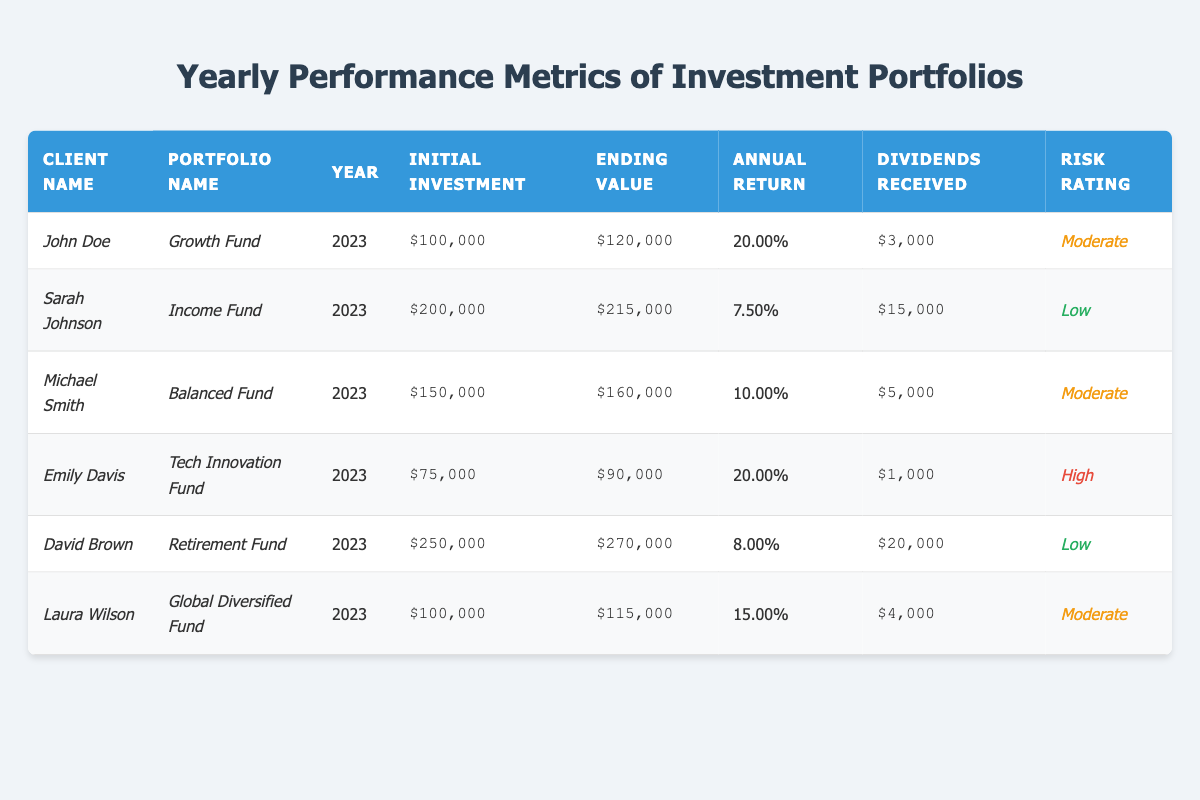What is the annual return percentage for John Doe's Growth Fund? The annual return percentage is listed directly next to John Doe's Growth Fund in the table, which reads 20.00%.
Answer: 20.00% How much did Sarah Johnson receive in dividends from the Income Fund? The table indicates that Sarah Johnson received $15,000 in dividends from the Income Fund.
Answer: $15,000 Which portfolio has the highest ending value? By looking through the ending values, David Brown's Retirement Fund has the highest ending value at $270,000.
Answer: $270,000 What is the average initial investment across all portfolios? The initial investments are $100,000, $200,000, $150,000, $75,000, $250,000, and $100,000. Adding these gives $875,000, and dividing by 6 portfolios results in an average of $145,833.33.
Answer: $145,833.33 Is Emily Davis's Tech Innovation Fund risk rating high? The risk rating for Emily Davis's Tech Innovation Fund is labeled "High" in the table.
Answer: Yes How much more ending value does David Brown's Retirement Fund have compared to Laura Wilson's Global Diversified Fund? David Brown's Retirement Fund has an ending value of $270,000 while Laura Wilson's Global Diversified Fund has $115,000. The difference is $270,000 - $115,000 = $155,000.
Answer: $155,000 Which client has the lowest expected annual return percentage? A comparison of annual return percentages shows Sarah Johnson's Income Fund with 7.5% is the lowest.
Answer: Sarah Johnson How many clients have a Moderate risk rating? The clients with a Moderate risk rating are John Doe, Michael Smith, and Laura Wilson. That totals 3 clients with Moderate risk ratings.
Answer: 3 What is the total amount of dividends received across all portfolios? The total dividends received are as follows: $3,000 + $15,000 + $5,000 + $1,000 + $20,000 + $4,000 = $48,000.
Answer: $48,000 Which portfolio underperformed in terms of annual return compared to the average of all portfolios? The average annual return can be calculated as (20 + 7.5 + 10 + 20 + 8 + 15) / 6 = 13.75%. The Under-performing portfolios compared to this average are Sarah Johnson's Income Fund (7.5%) and David Brown's Retirement Fund (8%).
Answer: Sarah Johnson's Income Fund and David Brown's Retirement Fund 